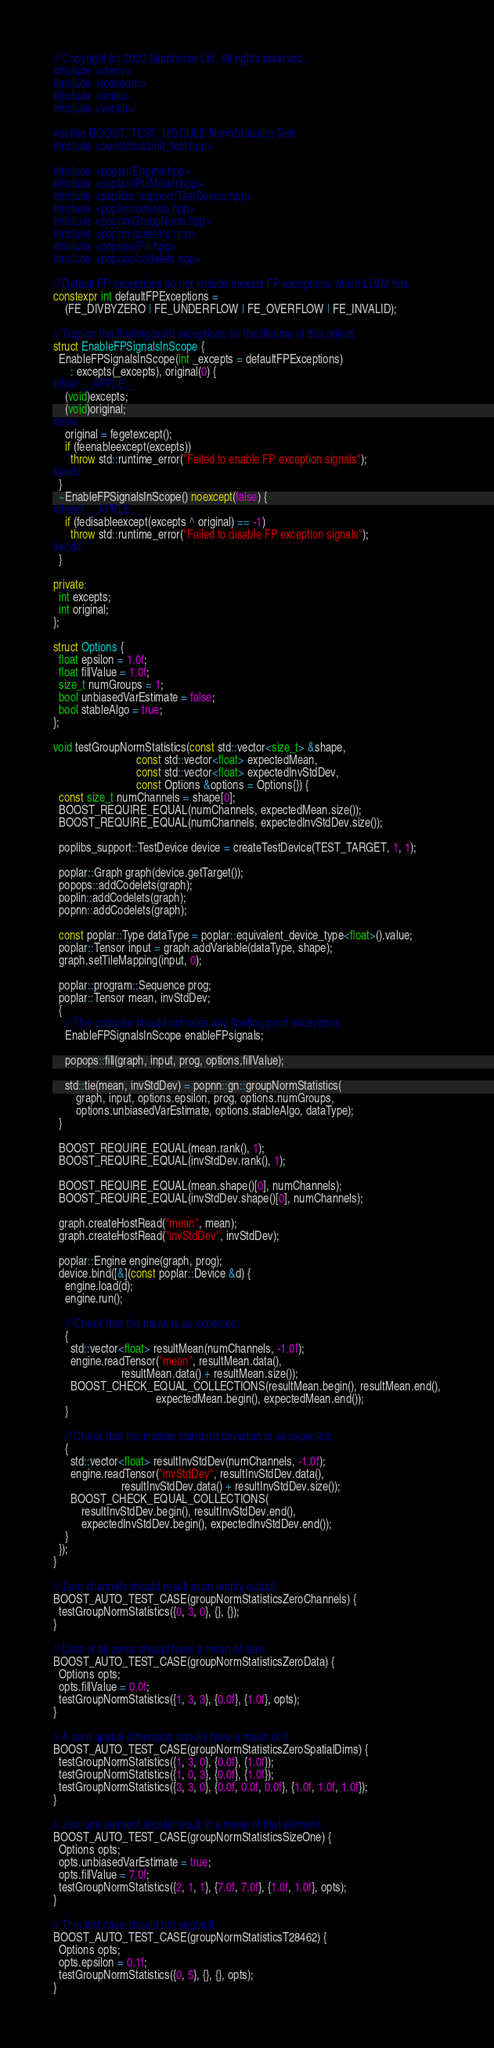<code> <loc_0><loc_0><loc_500><loc_500><_C++_>// Copyright (c) 2020 Graphcore Ltd. All rights reserved.
#include <cfenv>
#include <iostream>
#include <limits>
#include <vector>

#define BOOST_TEST_MODULE NormStatisticsTest
#include <boost/test/unit_test.hpp>

#include <poplar/Engine.hpp>
#include <poplar/IPUModel.hpp>
#include <poplibs_support/TestDevice.hpp>
#include <poplin/codelets.hpp>
#include <popnn/GroupNorm.hpp>
#include <popnn/codelets.hpp>
#include <popops/Fill.hpp>
#include <popops/codelets.hpp>

// Default FP exceptions do not include inexact FP exceptions which LLVM hits.
constexpr int defaultFPExceptions =
    (FE_DIVBYZERO | FE_UNDERFLOW | FE_OVERFLOW | FE_INVALID);

// Trap on the floating point exceptions for the lifetime of this object.
struct EnableFPSignalsInScope {
  EnableFPSignalsInScope(int _excepts = defaultFPExceptions)
      : excepts(_excepts), original(0) {
#ifdef __APPLE__
    (void)excepts;
    (void)original;
#else
    original = fegetexcept();
    if (feenableexcept(excepts))
      throw std::runtime_error("Failed to enable FP exception signals");
#endif
  }
  ~EnableFPSignalsInScope() noexcept(false) {
#ifndef __APPLE__
    if (fedisableexcept(excepts ^ original) == -1)
      throw std::runtime_error("Failed to disable FP exception signals");
#endif
  }

private:
  int excepts;
  int original;
};

struct Options {
  float epsilon = 1.0f;
  float fillValue = 1.0f;
  size_t numGroups = 1;
  bool unbiasedVarEstimate = false;
  bool stableAlgo = true;
};

void testGroupNormStatistics(const std::vector<size_t> &shape,
                             const std::vector<float> expectedMean,
                             const std::vector<float> expectedInvStdDev,
                             const Options &options = Options{}) {
  const size_t numChannels = shape[0];
  BOOST_REQUIRE_EQUAL(numChannels, expectedMean.size());
  BOOST_REQUIRE_EQUAL(numChannels, expectedInvStdDev.size());

  poplibs_support::TestDevice device = createTestDevice(TEST_TARGET, 1, 1);

  poplar::Graph graph(device.getTarget());
  popops::addCodelets(graph);
  poplin::addCodelets(graph);
  popnn::addCodelets(graph);

  const poplar::Type dataType = poplar::equivalent_device_type<float>().value;
  poplar::Tensor input = graph.addVariable(dataType, shape);
  graph.setTileMapping(input, 0);

  poplar::program::Sequence prog;
  poplar::Tensor mean, invStdDev;
  {
    // The compiler should not raise any floating point exceptions.
    EnableFPSignalsInScope enableFPsignals;

    popops::fill(graph, input, prog, options.fillValue);

    std::tie(mean, invStdDev) = popnn::gn::groupNormStatistics(
        graph, input, options.epsilon, prog, options.numGroups,
        options.unbiasedVarEstimate, options.stableAlgo, dataType);
  }

  BOOST_REQUIRE_EQUAL(mean.rank(), 1);
  BOOST_REQUIRE_EQUAL(invStdDev.rank(), 1);

  BOOST_REQUIRE_EQUAL(mean.shape()[0], numChannels);
  BOOST_REQUIRE_EQUAL(invStdDev.shape()[0], numChannels);

  graph.createHostRead("mean", mean);
  graph.createHostRead("invStdDev", invStdDev);

  poplar::Engine engine(graph, prog);
  device.bind([&](const poplar::Device &d) {
    engine.load(d);
    engine.run();

    // Check that the mean is as expected.
    {
      std::vector<float> resultMean(numChannels, -1.0f);
      engine.readTensor("mean", resultMean.data(),
                        resultMean.data() + resultMean.size());
      BOOST_CHECK_EQUAL_COLLECTIONS(resultMean.begin(), resultMean.end(),
                                    expectedMean.begin(), expectedMean.end());
    }

    // Check that the inverse standard deviation is as expected.
    {
      std::vector<float> resultInvStdDev(numChannels, -1.0f);
      engine.readTensor("invStdDev", resultInvStdDev.data(),
                        resultInvStdDev.data() + resultInvStdDev.size());
      BOOST_CHECK_EQUAL_COLLECTIONS(
          resultInvStdDev.begin(), resultInvStdDev.end(),
          expectedInvStdDev.begin(), expectedInvStdDev.end());
    }
  });
}

// Zero channels should result in an empty output.
BOOST_AUTO_TEST_CASE(groupNormStatisticsZeroChannels) {
  testGroupNormStatistics({0, 3, 0}, {}, {});
}

// Data of all zeros should have a mean of zero.
BOOST_AUTO_TEST_CASE(groupNormStatisticsZeroData) {
  Options opts;
  opts.fillValue = 0.0f;
  testGroupNormStatistics({1, 3, 3}, {0.0f}, {1.0f}, opts);
}

// A zero spatial dimension should have a mean of 0.
BOOST_AUTO_TEST_CASE(groupNormStatisticsZeroSpatialDims) {
  testGroupNormStatistics({1, 3, 0}, {0.0f}, {1.0f});
  testGroupNormStatistics({1, 0, 3}, {0.0f}, {1.0f});
  testGroupNormStatistics({3, 3, 0}, {0.0f, 0.0f, 0.0f}, {1.0f, 1.0f, 1.0f});
}

// Just one element should result in a mean of that element.
BOOST_AUTO_TEST_CASE(groupNormStatisticsSizeOne) {
  Options opts;
  opts.unbiasedVarEstimate = true;
  opts.fillValue = 7.0f;
  testGroupNormStatistics({2, 1, 1}, {7.0f, 7.0f}, {1.0f, 1.0f}, opts);
}

// This test case should not segfault.
BOOST_AUTO_TEST_CASE(groupNormStatisticsT28462) {
  Options opts;
  opts.epsilon = 0.1f;
  testGroupNormStatistics({0, 5}, {}, {}, opts);
}
</code> 